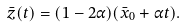Convert formula to latex. <formula><loc_0><loc_0><loc_500><loc_500>\bar { z } ( t ) = ( 1 - 2 \alpha ) ( \bar { x } _ { 0 } + \alpha t ) .</formula> 